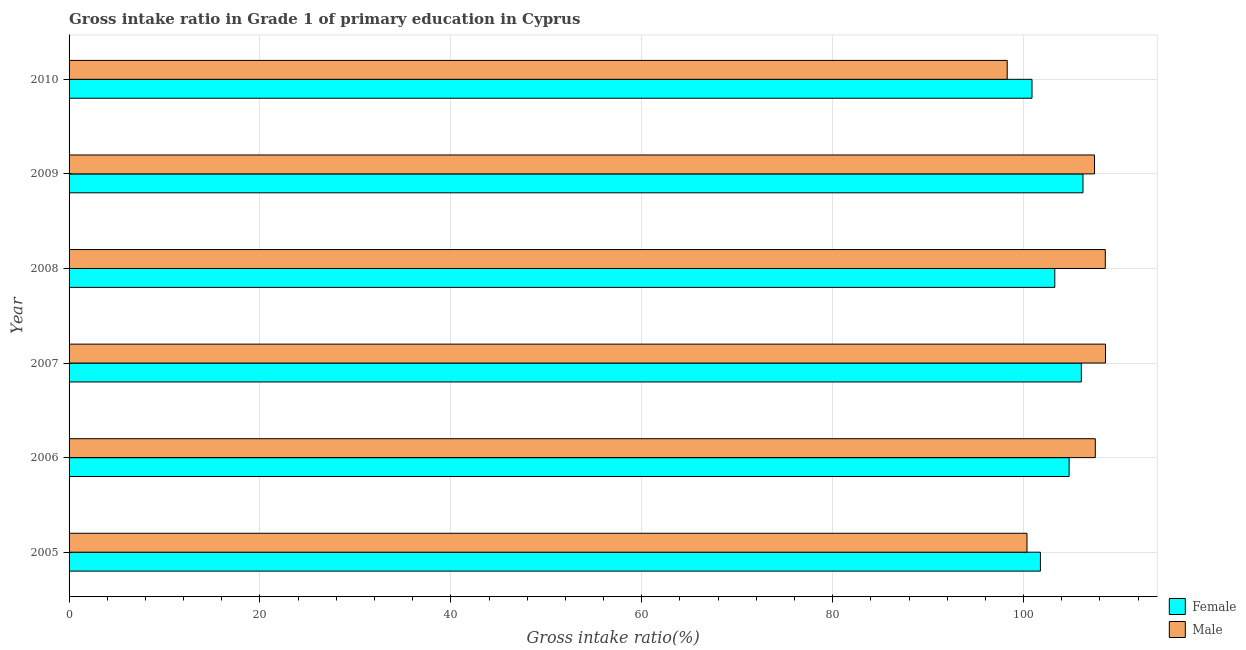How many groups of bars are there?
Your answer should be very brief. 6. Are the number of bars per tick equal to the number of legend labels?
Provide a succinct answer. Yes. Are the number of bars on each tick of the Y-axis equal?
Provide a succinct answer. Yes. What is the label of the 1st group of bars from the top?
Offer a terse response. 2010. In how many cases, is the number of bars for a given year not equal to the number of legend labels?
Your response must be concise. 0. What is the gross intake ratio(male) in 2006?
Keep it short and to the point. 107.52. Across all years, what is the maximum gross intake ratio(female)?
Offer a very short reply. 106.23. Across all years, what is the minimum gross intake ratio(male)?
Provide a short and direct response. 98.29. In which year was the gross intake ratio(female) minimum?
Your response must be concise. 2010. What is the total gross intake ratio(male) in the graph?
Keep it short and to the point. 630.76. What is the difference between the gross intake ratio(male) in 2007 and that in 2008?
Provide a short and direct response. 0.02. What is the difference between the gross intake ratio(female) in 2009 and the gross intake ratio(male) in 2006?
Ensure brevity in your answer.  -1.29. What is the average gross intake ratio(male) per year?
Your response must be concise. 105.13. In the year 2010, what is the difference between the gross intake ratio(male) and gross intake ratio(female)?
Offer a terse response. -2.6. What is the ratio of the gross intake ratio(female) in 2006 to that in 2008?
Give a very brief answer. 1.01. Is the gross intake ratio(male) in 2007 less than that in 2009?
Keep it short and to the point. No. What is the difference between the highest and the second highest gross intake ratio(female)?
Ensure brevity in your answer.  0.17. What is the difference between the highest and the lowest gross intake ratio(female)?
Give a very brief answer. 5.34. In how many years, is the gross intake ratio(male) greater than the average gross intake ratio(male) taken over all years?
Make the answer very short. 4. Is the sum of the gross intake ratio(male) in 2005 and 2008 greater than the maximum gross intake ratio(female) across all years?
Give a very brief answer. Yes. How many bars are there?
Give a very brief answer. 12. What is the difference between two consecutive major ticks on the X-axis?
Keep it short and to the point. 20. Does the graph contain any zero values?
Offer a terse response. No. Where does the legend appear in the graph?
Your answer should be very brief. Bottom right. What is the title of the graph?
Make the answer very short. Gross intake ratio in Grade 1 of primary education in Cyprus. What is the label or title of the X-axis?
Ensure brevity in your answer.  Gross intake ratio(%). What is the label or title of the Y-axis?
Give a very brief answer. Year. What is the Gross intake ratio(%) in Female in 2005?
Make the answer very short. 101.77. What is the Gross intake ratio(%) of Male in 2005?
Offer a very short reply. 100.36. What is the Gross intake ratio(%) of Female in 2006?
Your answer should be very brief. 104.77. What is the Gross intake ratio(%) in Male in 2006?
Offer a very short reply. 107.52. What is the Gross intake ratio(%) in Female in 2007?
Ensure brevity in your answer.  106.05. What is the Gross intake ratio(%) in Male in 2007?
Offer a terse response. 108.58. What is the Gross intake ratio(%) in Female in 2008?
Give a very brief answer. 103.27. What is the Gross intake ratio(%) of Male in 2008?
Give a very brief answer. 108.57. What is the Gross intake ratio(%) of Female in 2009?
Offer a terse response. 106.23. What is the Gross intake ratio(%) in Male in 2009?
Keep it short and to the point. 107.44. What is the Gross intake ratio(%) in Female in 2010?
Provide a short and direct response. 100.89. What is the Gross intake ratio(%) in Male in 2010?
Make the answer very short. 98.29. Across all years, what is the maximum Gross intake ratio(%) in Female?
Provide a succinct answer. 106.23. Across all years, what is the maximum Gross intake ratio(%) of Male?
Make the answer very short. 108.58. Across all years, what is the minimum Gross intake ratio(%) of Female?
Your answer should be very brief. 100.89. Across all years, what is the minimum Gross intake ratio(%) of Male?
Provide a succinct answer. 98.29. What is the total Gross intake ratio(%) in Female in the graph?
Make the answer very short. 622.99. What is the total Gross intake ratio(%) in Male in the graph?
Ensure brevity in your answer.  630.76. What is the difference between the Gross intake ratio(%) of Female in 2005 and that in 2006?
Give a very brief answer. -3.01. What is the difference between the Gross intake ratio(%) of Male in 2005 and that in 2006?
Offer a very short reply. -7.16. What is the difference between the Gross intake ratio(%) of Female in 2005 and that in 2007?
Provide a short and direct response. -4.29. What is the difference between the Gross intake ratio(%) of Male in 2005 and that in 2007?
Your answer should be very brief. -8.22. What is the difference between the Gross intake ratio(%) in Female in 2005 and that in 2008?
Your answer should be very brief. -1.51. What is the difference between the Gross intake ratio(%) in Male in 2005 and that in 2008?
Keep it short and to the point. -8.2. What is the difference between the Gross intake ratio(%) of Female in 2005 and that in 2009?
Your answer should be compact. -4.46. What is the difference between the Gross intake ratio(%) in Male in 2005 and that in 2009?
Keep it short and to the point. -7.08. What is the difference between the Gross intake ratio(%) of Female in 2005 and that in 2010?
Your response must be concise. 0.88. What is the difference between the Gross intake ratio(%) of Male in 2005 and that in 2010?
Offer a terse response. 2.07. What is the difference between the Gross intake ratio(%) of Female in 2006 and that in 2007?
Provide a short and direct response. -1.28. What is the difference between the Gross intake ratio(%) in Male in 2006 and that in 2007?
Offer a terse response. -1.07. What is the difference between the Gross intake ratio(%) of Female in 2006 and that in 2008?
Your response must be concise. 1.5. What is the difference between the Gross intake ratio(%) of Male in 2006 and that in 2008?
Ensure brevity in your answer.  -1.05. What is the difference between the Gross intake ratio(%) in Female in 2006 and that in 2009?
Provide a short and direct response. -1.45. What is the difference between the Gross intake ratio(%) in Male in 2006 and that in 2009?
Offer a terse response. 0.08. What is the difference between the Gross intake ratio(%) in Female in 2006 and that in 2010?
Make the answer very short. 3.89. What is the difference between the Gross intake ratio(%) of Male in 2006 and that in 2010?
Make the answer very short. 9.23. What is the difference between the Gross intake ratio(%) in Female in 2007 and that in 2008?
Make the answer very short. 2.78. What is the difference between the Gross intake ratio(%) in Male in 2007 and that in 2008?
Give a very brief answer. 0.02. What is the difference between the Gross intake ratio(%) of Female in 2007 and that in 2009?
Provide a short and direct response. -0.17. What is the difference between the Gross intake ratio(%) in Male in 2007 and that in 2009?
Offer a very short reply. 1.15. What is the difference between the Gross intake ratio(%) of Female in 2007 and that in 2010?
Your response must be concise. 5.17. What is the difference between the Gross intake ratio(%) of Male in 2007 and that in 2010?
Offer a very short reply. 10.3. What is the difference between the Gross intake ratio(%) of Female in 2008 and that in 2009?
Make the answer very short. -2.95. What is the difference between the Gross intake ratio(%) in Male in 2008 and that in 2009?
Your answer should be very brief. 1.13. What is the difference between the Gross intake ratio(%) of Female in 2008 and that in 2010?
Keep it short and to the point. 2.39. What is the difference between the Gross intake ratio(%) in Male in 2008 and that in 2010?
Your response must be concise. 10.28. What is the difference between the Gross intake ratio(%) of Female in 2009 and that in 2010?
Offer a very short reply. 5.34. What is the difference between the Gross intake ratio(%) in Male in 2009 and that in 2010?
Ensure brevity in your answer.  9.15. What is the difference between the Gross intake ratio(%) of Female in 2005 and the Gross intake ratio(%) of Male in 2006?
Make the answer very short. -5.75. What is the difference between the Gross intake ratio(%) in Female in 2005 and the Gross intake ratio(%) in Male in 2007?
Make the answer very short. -6.82. What is the difference between the Gross intake ratio(%) of Female in 2005 and the Gross intake ratio(%) of Male in 2008?
Make the answer very short. -6.8. What is the difference between the Gross intake ratio(%) of Female in 2005 and the Gross intake ratio(%) of Male in 2009?
Offer a very short reply. -5.67. What is the difference between the Gross intake ratio(%) in Female in 2005 and the Gross intake ratio(%) in Male in 2010?
Make the answer very short. 3.48. What is the difference between the Gross intake ratio(%) of Female in 2006 and the Gross intake ratio(%) of Male in 2007?
Give a very brief answer. -3.81. What is the difference between the Gross intake ratio(%) of Female in 2006 and the Gross intake ratio(%) of Male in 2008?
Offer a very short reply. -3.79. What is the difference between the Gross intake ratio(%) of Female in 2006 and the Gross intake ratio(%) of Male in 2009?
Your answer should be very brief. -2.66. What is the difference between the Gross intake ratio(%) in Female in 2006 and the Gross intake ratio(%) in Male in 2010?
Offer a very short reply. 6.49. What is the difference between the Gross intake ratio(%) of Female in 2007 and the Gross intake ratio(%) of Male in 2008?
Your answer should be compact. -2.51. What is the difference between the Gross intake ratio(%) of Female in 2007 and the Gross intake ratio(%) of Male in 2009?
Keep it short and to the point. -1.38. What is the difference between the Gross intake ratio(%) of Female in 2007 and the Gross intake ratio(%) of Male in 2010?
Your answer should be compact. 7.77. What is the difference between the Gross intake ratio(%) in Female in 2008 and the Gross intake ratio(%) in Male in 2009?
Offer a very short reply. -4.16. What is the difference between the Gross intake ratio(%) of Female in 2008 and the Gross intake ratio(%) of Male in 2010?
Offer a terse response. 4.99. What is the difference between the Gross intake ratio(%) in Female in 2009 and the Gross intake ratio(%) in Male in 2010?
Your answer should be compact. 7.94. What is the average Gross intake ratio(%) in Female per year?
Your answer should be compact. 103.83. What is the average Gross intake ratio(%) of Male per year?
Offer a terse response. 105.13. In the year 2005, what is the difference between the Gross intake ratio(%) in Female and Gross intake ratio(%) in Male?
Your response must be concise. 1.41. In the year 2006, what is the difference between the Gross intake ratio(%) of Female and Gross intake ratio(%) of Male?
Keep it short and to the point. -2.75. In the year 2007, what is the difference between the Gross intake ratio(%) in Female and Gross intake ratio(%) in Male?
Give a very brief answer. -2.53. In the year 2008, what is the difference between the Gross intake ratio(%) of Female and Gross intake ratio(%) of Male?
Your answer should be compact. -5.29. In the year 2009, what is the difference between the Gross intake ratio(%) of Female and Gross intake ratio(%) of Male?
Give a very brief answer. -1.21. In the year 2010, what is the difference between the Gross intake ratio(%) in Female and Gross intake ratio(%) in Male?
Make the answer very short. 2.6. What is the ratio of the Gross intake ratio(%) of Female in 2005 to that in 2006?
Offer a very short reply. 0.97. What is the ratio of the Gross intake ratio(%) of Male in 2005 to that in 2006?
Provide a succinct answer. 0.93. What is the ratio of the Gross intake ratio(%) of Female in 2005 to that in 2007?
Keep it short and to the point. 0.96. What is the ratio of the Gross intake ratio(%) in Male in 2005 to that in 2007?
Give a very brief answer. 0.92. What is the ratio of the Gross intake ratio(%) in Female in 2005 to that in 2008?
Provide a short and direct response. 0.99. What is the ratio of the Gross intake ratio(%) of Male in 2005 to that in 2008?
Keep it short and to the point. 0.92. What is the ratio of the Gross intake ratio(%) in Female in 2005 to that in 2009?
Provide a short and direct response. 0.96. What is the ratio of the Gross intake ratio(%) in Male in 2005 to that in 2009?
Provide a succinct answer. 0.93. What is the ratio of the Gross intake ratio(%) in Female in 2005 to that in 2010?
Provide a succinct answer. 1.01. What is the ratio of the Gross intake ratio(%) in Male in 2005 to that in 2010?
Your answer should be compact. 1.02. What is the ratio of the Gross intake ratio(%) of Female in 2006 to that in 2007?
Offer a very short reply. 0.99. What is the ratio of the Gross intake ratio(%) of Male in 2006 to that in 2007?
Offer a terse response. 0.99. What is the ratio of the Gross intake ratio(%) in Female in 2006 to that in 2008?
Provide a succinct answer. 1.01. What is the ratio of the Gross intake ratio(%) in Male in 2006 to that in 2008?
Keep it short and to the point. 0.99. What is the ratio of the Gross intake ratio(%) in Female in 2006 to that in 2009?
Your answer should be very brief. 0.99. What is the ratio of the Gross intake ratio(%) in Female in 2006 to that in 2010?
Offer a terse response. 1.04. What is the ratio of the Gross intake ratio(%) in Male in 2006 to that in 2010?
Your answer should be compact. 1.09. What is the ratio of the Gross intake ratio(%) in Female in 2007 to that in 2008?
Give a very brief answer. 1.03. What is the ratio of the Gross intake ratio(%) in Male in 2007 to that in 2009?
Offer a very short reply. 1.01. What is the ratio of the Gross intake ratio(%) of Female in 2007 to that in 2010?
Provide a succinct answer. 1.05. What is the ratio of the Gross intake ratio(%) in Male in 2007 to that in 2010?
Ensure brevity in your answer.  1.1. What is the ratio of the Gross intake ratio(%) of Female in 2008 to that in 2009?
Offer a terse response. 0.97. What is the ratio of the Gross intake ratio(%) in Male in 2008 to that in 2009?
Offer a very short reply. 1.01. What is the ratio of the Gross intake ratio(%) of Female in 2008 to that in 2010?
Your answer should be very brief. 1.02. What is the ratio of the Gross intake ratio(%) in Male in 2008 to that in 2010?
Make the answer very short. 1.1. What is the ratio of the Gross intake ratio(%) in Female in 2009 to that in 2010?
Offer a very short reply. 1.05. What is the ratio of the Gross intake ratio(%) in Male in 2009 to that in 2010?
Keep it short and to the point. 1.09. What is the difference between the highest and the second highest Gross intake ratio(%) in Female?
Your answer should be compact. 0.17. What is the difference between the highest and the second highest Gross intake ratio(%) in Male?
Ensure brevity in your answer.  0.02. What is the difference between the highest and the lowest Gross intake ratio(%) in Female?
Give a very brief answer. 5.34. What is the difference between the highest and the lowest Gross intake ratio(%) in Male?
Offer a very short reply. 10.3. 